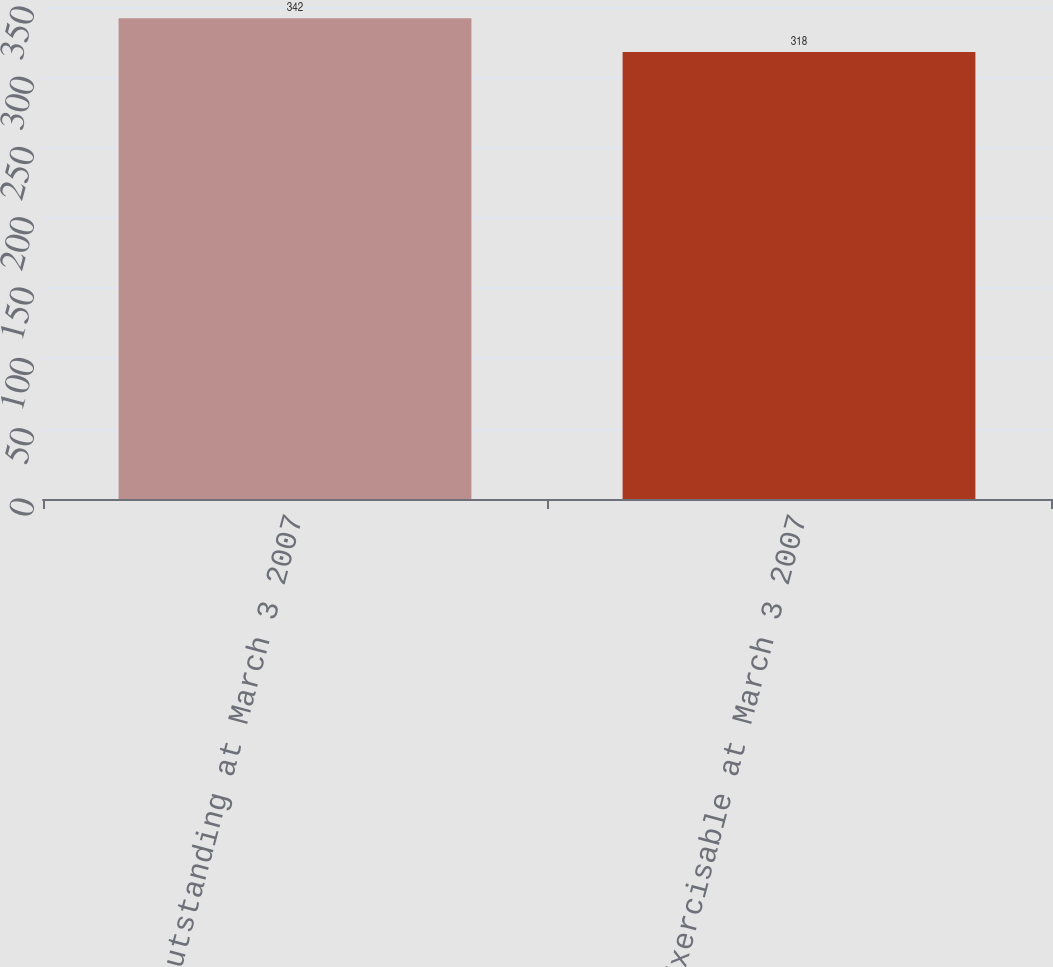<chart> <loc_0><loc_0><loc_500><loc_500><bar_chart><fcel>Outstanding at March 3 2007<fcel>Exercisable at March 3 2007<nl><fcel>342<fcel>318<nl></chart> 